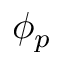<formula> <loc_0><loc_0><loc_500><loc_500>\phi _ { p }</formula> 